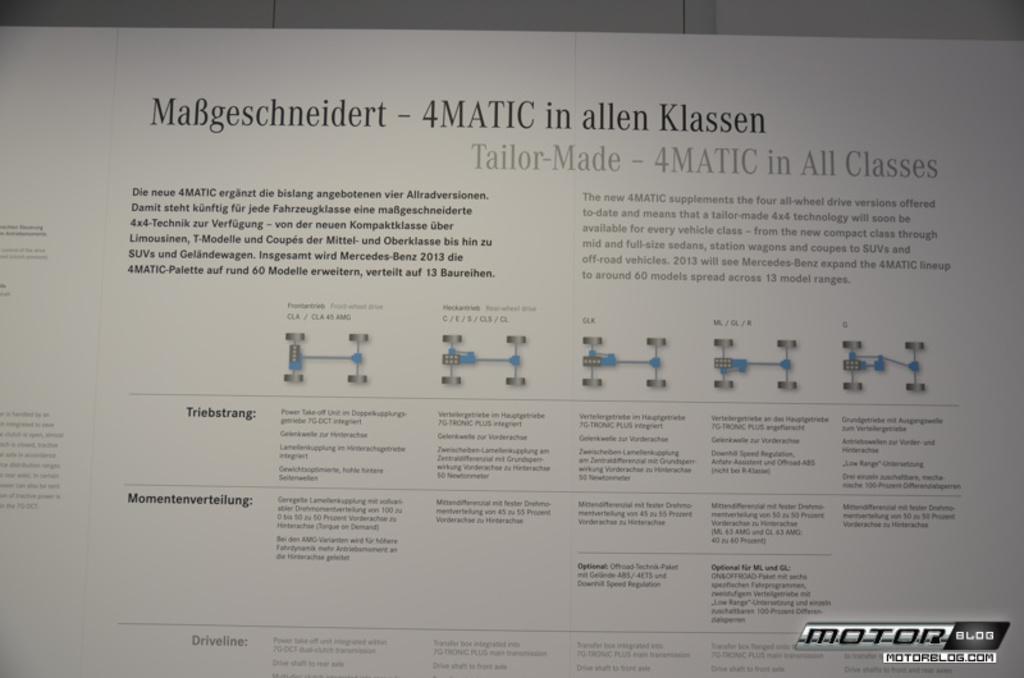Do you understand what mabgeschneidert - 4matic in allen klassen topic speaks about?
Your response must be concise. Answering does not require reading text in the image. Is the smaller text written in english?
Give a very brief answer. No. 